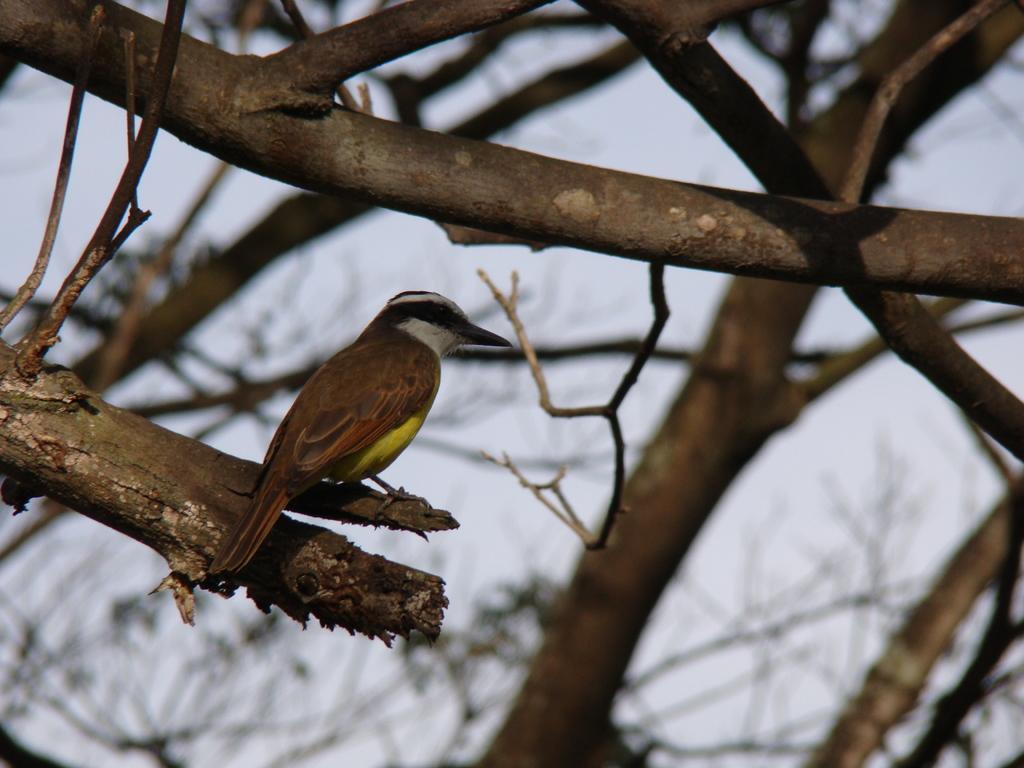Describe this image in one or two sentences. In this image I can see a bird standing on the branch. Bird is in brown,yellow black and white color. The sky is in white color. 